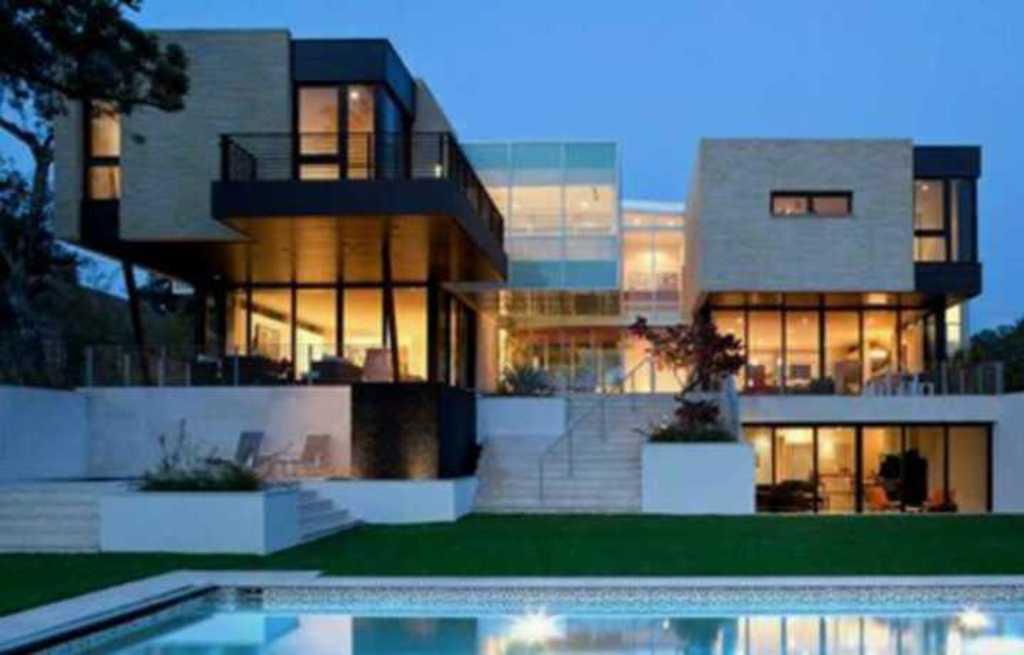Could you give a brief overview of what you see in this image? In this image we can see the front view of a building. Image also consists of trees, plants and also grass. We can also see a swimming pool, stairs. At the top sky is visible. 